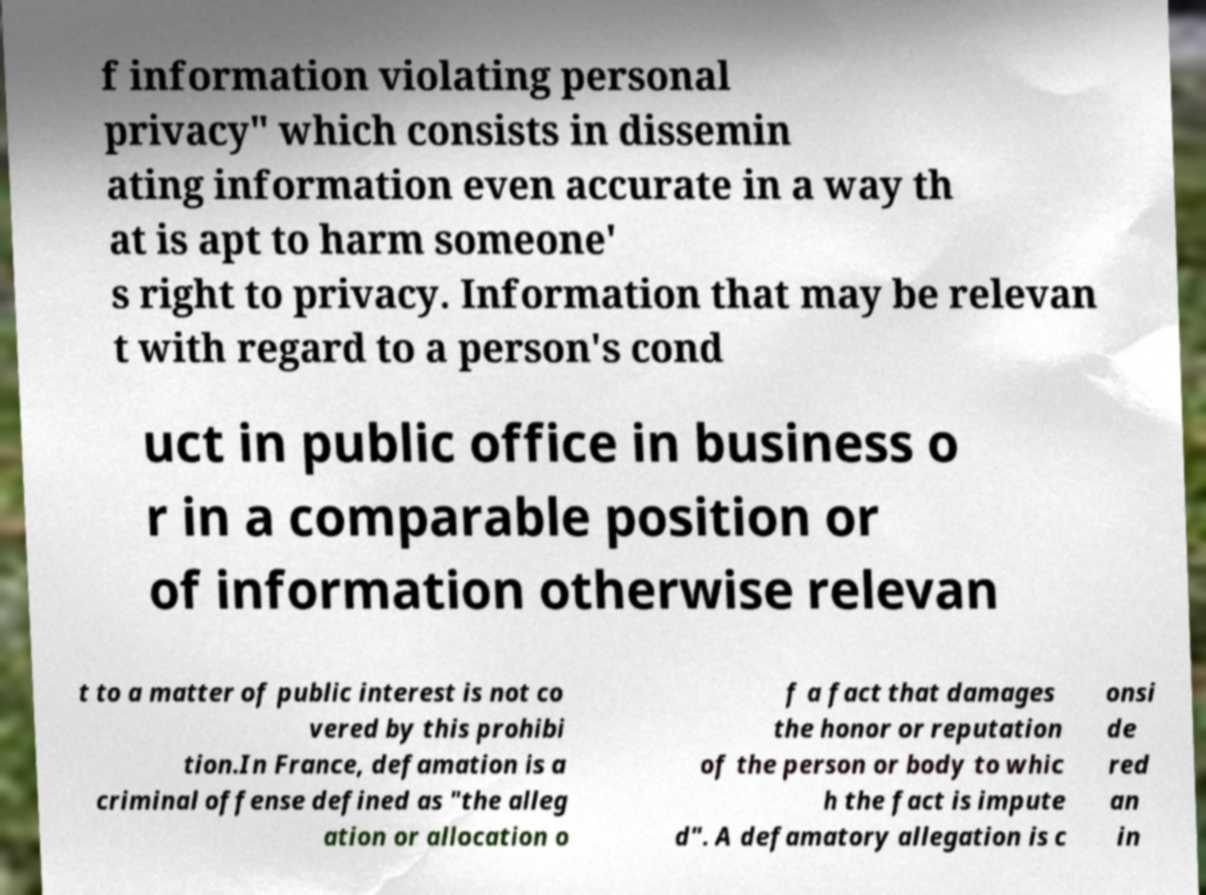Please identify and transcribe the text found in this image. f information violating personal privacy" which consists in dissemin ating information even accurate in a way th at is apt to harm someone' s right to privacy. Information that may be relevan t with regard to a person's cond uct in public office in business o r in a comparable position or of information otherwise relevan t to a matter of public interest is not co vered by this prohibi tion.In France, defamation is a criminal offense defined as "the alleg ation or allocation o f a fact that damages the honor or reputation of the person or body to whic h the fact is impute d". A defamatory allegation is c onsi de red an in 